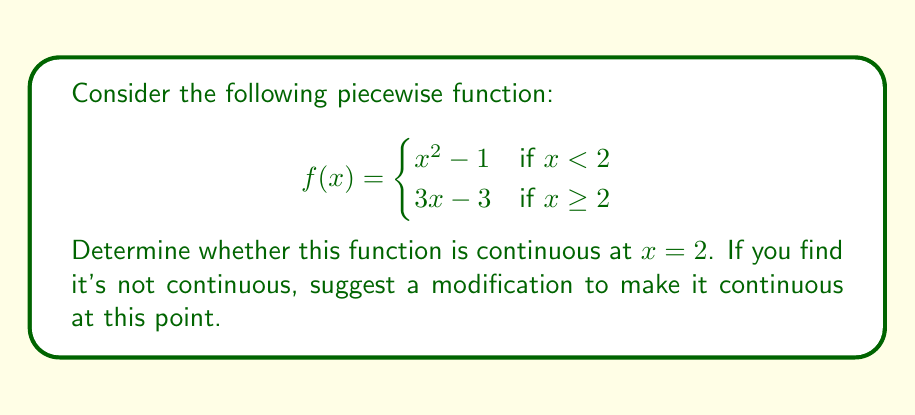Could you help me with this problem? To determine if the function is continuous at $x = 2$, we need to check three conditions:

1. $f(2)$ exists
2. $\lim_{x \to 2^-} f(x)$ exists
3. $\lim_{x \to 2^+} f(x)$ exists
4. All three values are equal

Step 1: Find $f(2)$
Since $x \geq 2$, we use the second piece of the function:
$f(2) = 3(2) - 3 = 6 - 3 = 3$

Step 2: Find $\lim_{x \to 2^-} f(x)$
As $x$ approaches 2 from the left, we use the first piece:
$\lim_{x \to 2^-} f(x) = \lim_{x \to 2^-} (x^2 - 1) = 2^2 - 1 = 4 - 1 = 3$

Step 3: Find $\lim_{x \to 2^+} f(x)$
As $x$ approaches 2 from the right, we use the second piece:
$\lim_{x \to 2^+} f(x) = \lim_{x \to 2^+} (3x - 3) = 3(2) - 3 = 6 - 3 = 3$

Step 4: Compare the values
$f(2) = 3$
$\lim_{x \to 2^-} f(x) = 3$
$\lim_{x \to 2^+} f(x) = 3$

All three values are equal to 3, so the function is continuous at $x = 2$.

No modification is needed as the function is already continuous at this point.
Answer: The function is continuous at $x = 2$. 